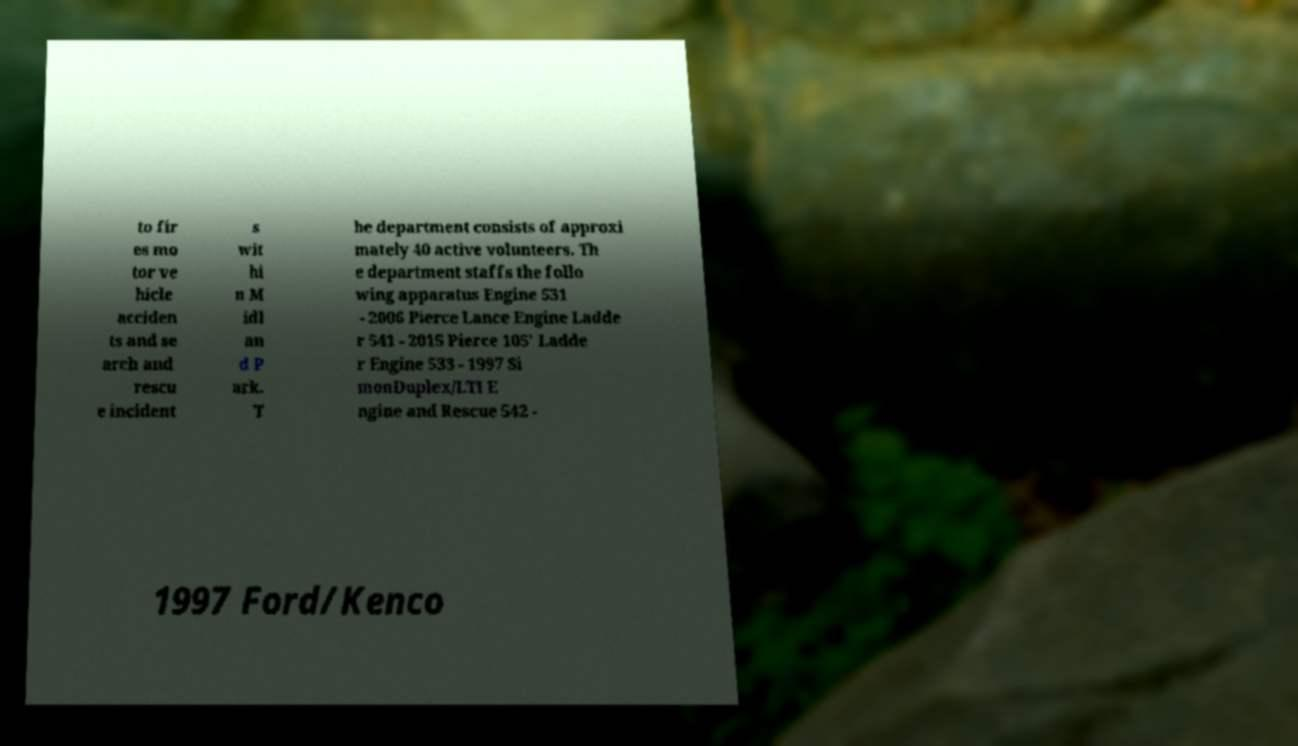Can you accurately transcribe the text from the provided image for me? to fir es mo tor ve hicle acciden ts and se arch and rescu e incident s wit hi n M idl an d P ark. T he department consists of approxi mately 40 active volunteers. Th e department staffs the follo wing apparatus Engine 531 - 2006 Pierce Lance Engine Ladde r 541 - 2015 Pierce 105' Ladde r Engine 533 - 1997 Si monDuplex/LTI E ngine and Rescue 542 - 1997 Ford/Kenco 